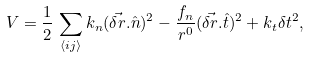<formula> <loc_0><loc_0><loc_500><loc_500>V = \frac { 1 } { 2 } \, \sum _ { \langle i j \rangle } k _ { n } ( \vec { \delta r } . \hat { n } ) ^ { 2 } - \frac { f _ { n } } { r ^ { 0 } } ( \vec { \delta r } . \hat { t } ) ^ { 2 } + k _ { t } \delta t ^ { 2 } ,</formula> 